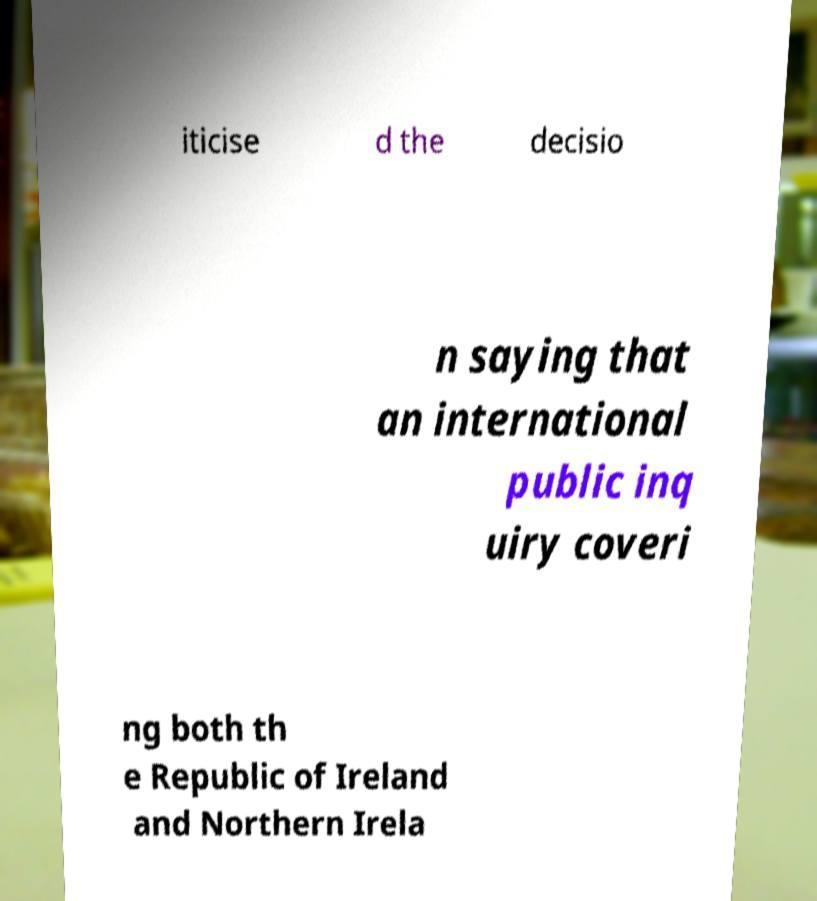For documentation purposes, I need the text within this image transcribed. Could you provide that? iticise d the decisio n saying that an international public inq uiry coveri ng both th e Republic of Ireland and Northern Irela 